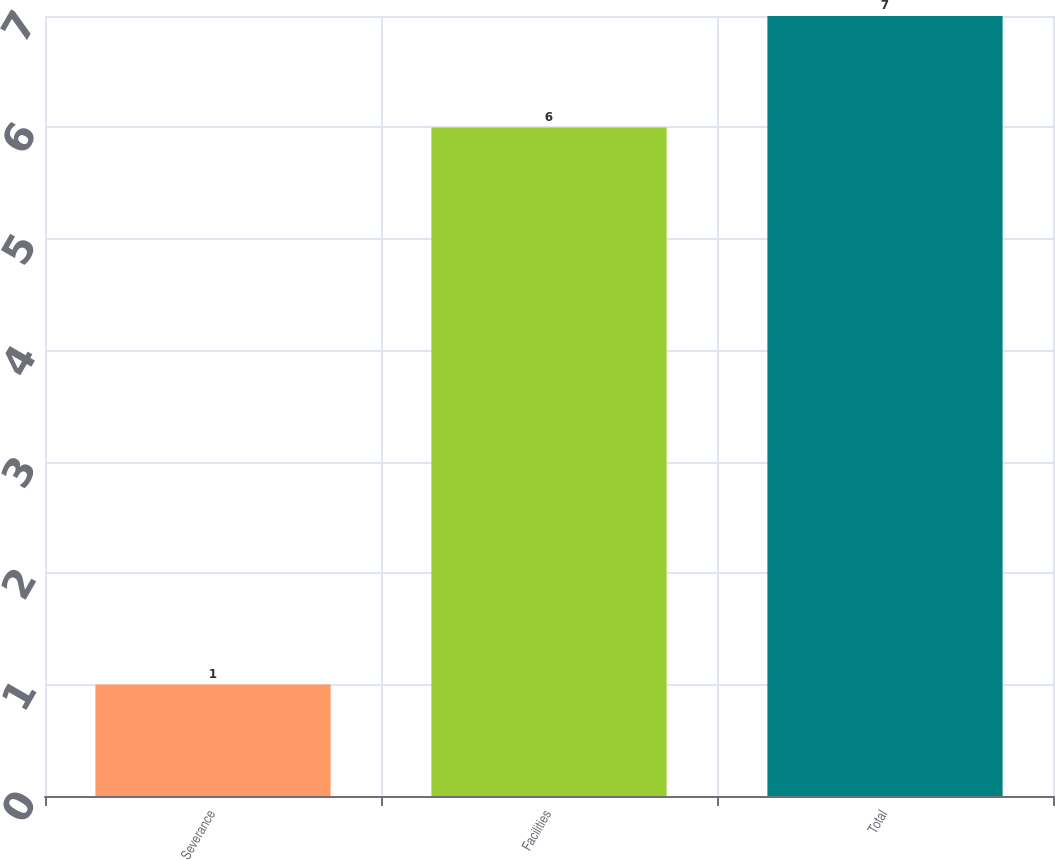Convert chart. <chart><loc_0><loc_0><loc_500><loc_500><bar_chart><fcel>Severance<fcel>Facilities<fcel>Total<nl><fcel>1<fcel>6<fcel>7<nl></chart> 